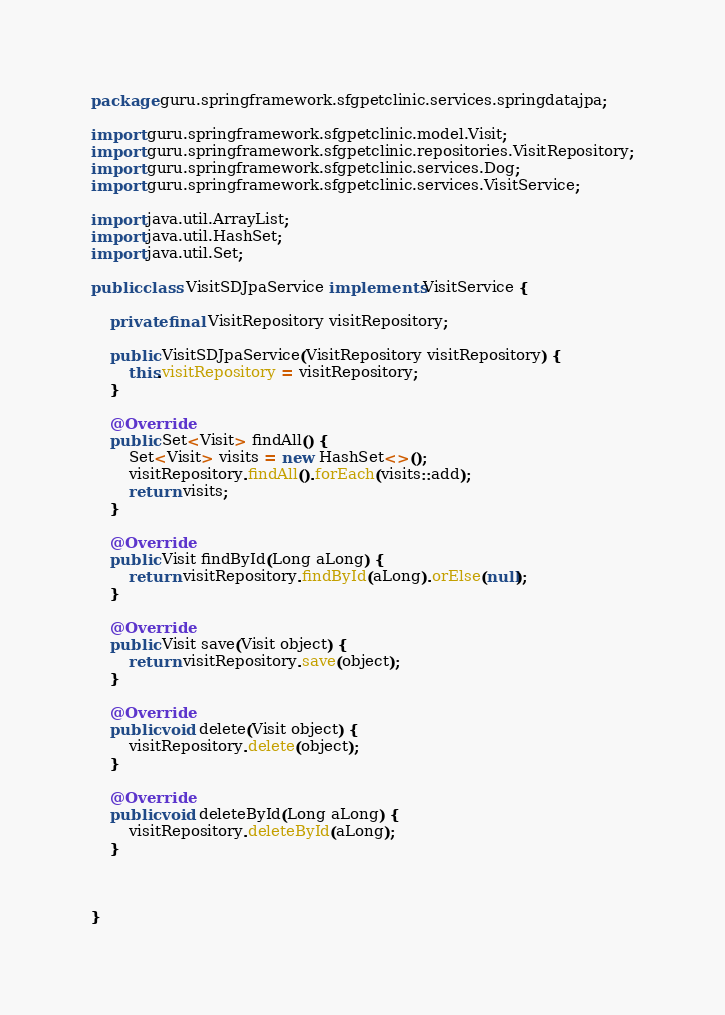Convert code to text. <code><loc_0><loc_0><loc_500><loc_500><_Java_>package guru.springframework.sfgpetclinic.services.springdatajpa;

import guru.springframework.sfgpetclinic.model.Visit;
import guru.springframework.sfgpetclinic.repositories.VisitRepository;
import guru.springframework.sfgpetclinic.services.Dog;
import guru.springframework.sfgpetclinic.services.VisitService;

import java.util.ArrayList;
import java.util.HashSet;
import java.util.Set;

public class VisitSDJpaService implements VisitService {

    private final VisitRepository visitRepository;

    public VisitSDJpaService(VisitRepository visitRepository) {
        this.visitRepository = visitRepository;
    }

    @Override
    public Set<Visit> findAll() {
        Set<Visit> visits = new HashSet<>();
        visitRepository.findAll().forEach(visits::add);
        return visits;
    }

    @Override
    public Visit findById(Long aLong) {
        return visitRepository.findById(aLong).orElse(null);
    }

    @Override
    public Visit save(Visit object) {
        return visitRepository.save(object);
    }

    @Override
    public void delete(Visit object) {
        visitRepository.delete(object);
    }

    @Override
    public void deleteById(Long aLong) {
        visitRepository.deleteById(aLong);
    }



}
</code> 